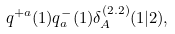<formula> <loc_0><loc_0><loc_500><loc_500>q ^ { + a } ( 1 ) q ^ { - } _ { a } ( 1 ) \delta ^ { ( 2 . 2 ) } _ { A } ( 1 | 2 ) ,</formula> 